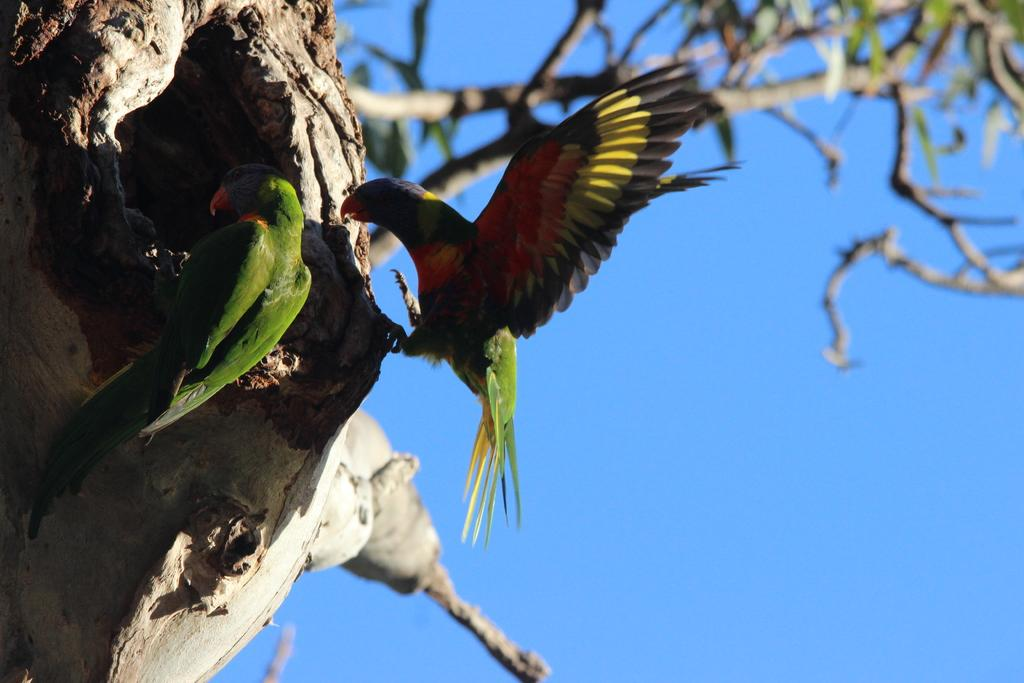How many parrots are in the image? There are two parrots in the image. Where are the parrots located? The parrots are on a tree. What can be seen in the background of the image? The background is blurred. What is visible in the sky in the image? The sky is visible in the image. What country is the parrot from in the image? The image does not provide information about the country of origin of the parrots. Can you describe the wave pattern in the image? There is no wave pattern present in the image. 